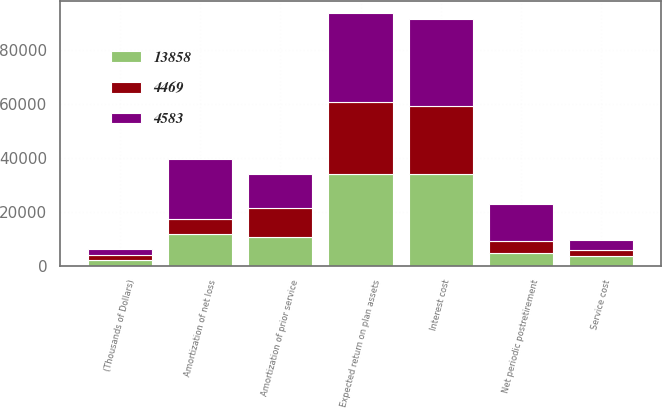Convert chart to OTSL. <chart><loc_0><loc_0><loc_500><loc_500><stacked_bar_chart><ecel><fcel>(Thousands of Dollars)<fcel>Service cost<fcel>Interest cost<fcel>Expected return on plan assets<fcel>Amortization of prior service<fcel>Amortization of net loss<fcel>Net periodic postretirement<nl><fcel>4469<fcel>2015<fcel>2116<fcel>25297<fcel>26600<fcel>10686<fcel>5404<fcel>4469<nl><fcel>13858<fcel>2014<fcel>3457<fcel>34028<fcel>33954<fcel>10688<fcel>11740<fcel>4583<nl><fcel>4583<fcel>2013<fcel>4079<fcel>32141<fcel>33011<fcel>12501<fcel>22325<fcel>13858<nl></chart> 